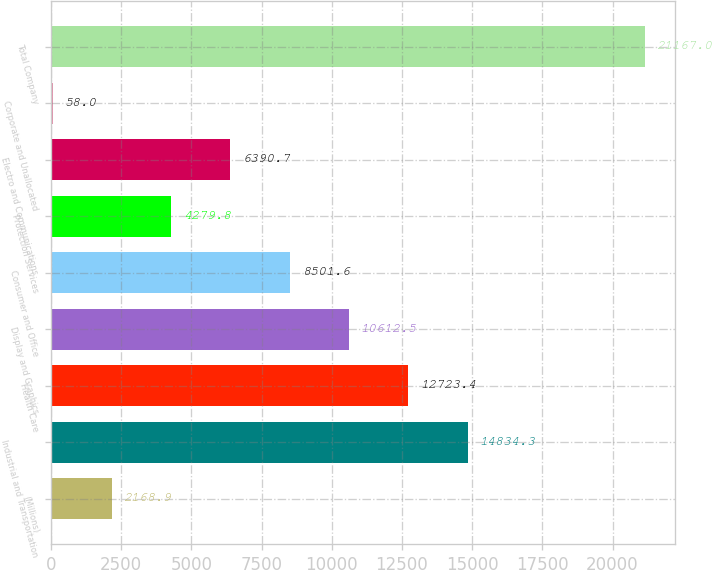Convert chart. <chart><loc_0><loc_0><loc_500><loc_500><bar_chart><fcel>(Millions)<fcel>Industrial and Transportation<fcel>Health Care<fcel>Display and Graphics<fcel>Consumer and Office<fcel>Protection Services<fcel>Electro and Communications<fcel>Corporate and Unallocated<fcel>Total Company<nl><fcel>2168.9<fcel>14834.3<fcel>12723.4<fcel>10612.5<fcel>8501.6<fcel>4279.8<fcel>6390.7<fcel>58<fcel>21167<nl></chart> 